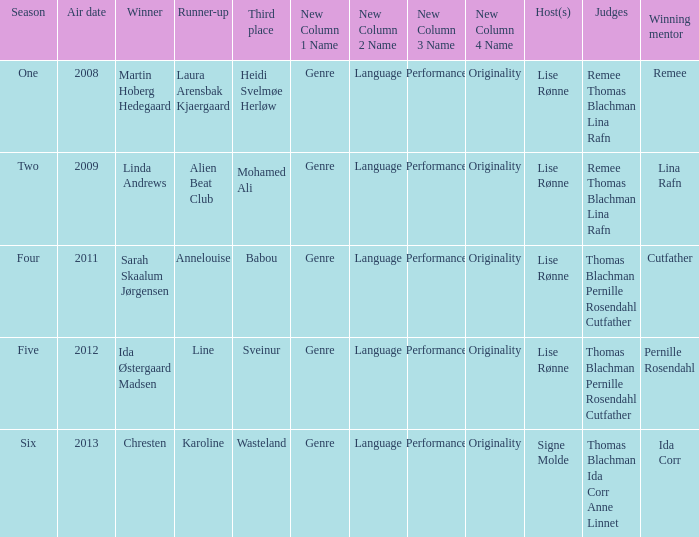Who was the runner-up in season five? Line. 